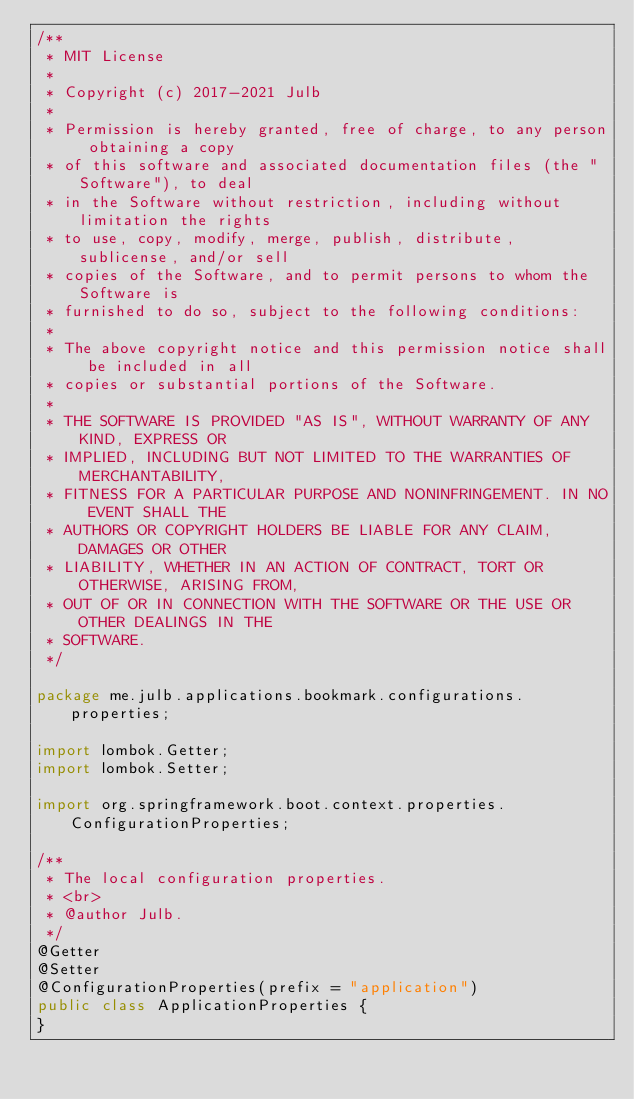<code> <loc_0><loc_0><loc_500><loc_500><_Java_>/**
 * MIT License
 *
 * Copyright (c) 2017-2021 Julb
 *
 * Permission is hereby granted, free of charge, to any person obtaining a copy
 * of this software and associated documentation files (the "Software"), to deal
 * in the Software without restriction, including without limitation the rights
 * to use, copy, modify, merge, publish, distribute, sublicense, and/or sell
 * copies of the Software, and to permit persons to whom the Software is
 * furnished to do so, subject to the following conditions:
 *
 * The above copyright notice and this permission notice shall be included in all
 * copies or substantial portions of the Software.
 *
 * THE SOFTWARE IS PROVIDED "AS IS", WITHOUT WARRANTY OF ANY KIND, EXPRESS OR
 * IMPLIED, INCLUDING BUT NOT LIMITED TO THE WARRANTIES OF MERCHANTABILITY,
 * FITNESS FOR A PARTICULAR PURPOSE AND NONINFRINGEMENT. IN NO EVENT SHALL THE
 * AUTHORS OR COPYRIGHT HOLDERS BE LIABLE FOR ANY CLAIM, DAMAGES OR OTHER
 * LIABILITY, WHETHER IN AN ACTION OF CONTRACT, TORT OR OTHERWISE, ARISING FROM,
 * OUT OF OR IN CONNECTION WITH THE SOFTWARE OR THE USE OR OTHER DEALINGS IN THE
 * SOFTWARE.
 */

package me.julb.applications.bookmark.configurations.properties;

import lombok.Getter;
import lombok.Setter;

import org.springframework.boot.context.properties.ConfigurationProperties;

/**
 * The local configuration properties.
 * <br>
 * @author Julb.
 */
@Getter
@Setter
@ConfigurationProperties(prefix = "application")
public class ApplicationProperties {
}
</code> 